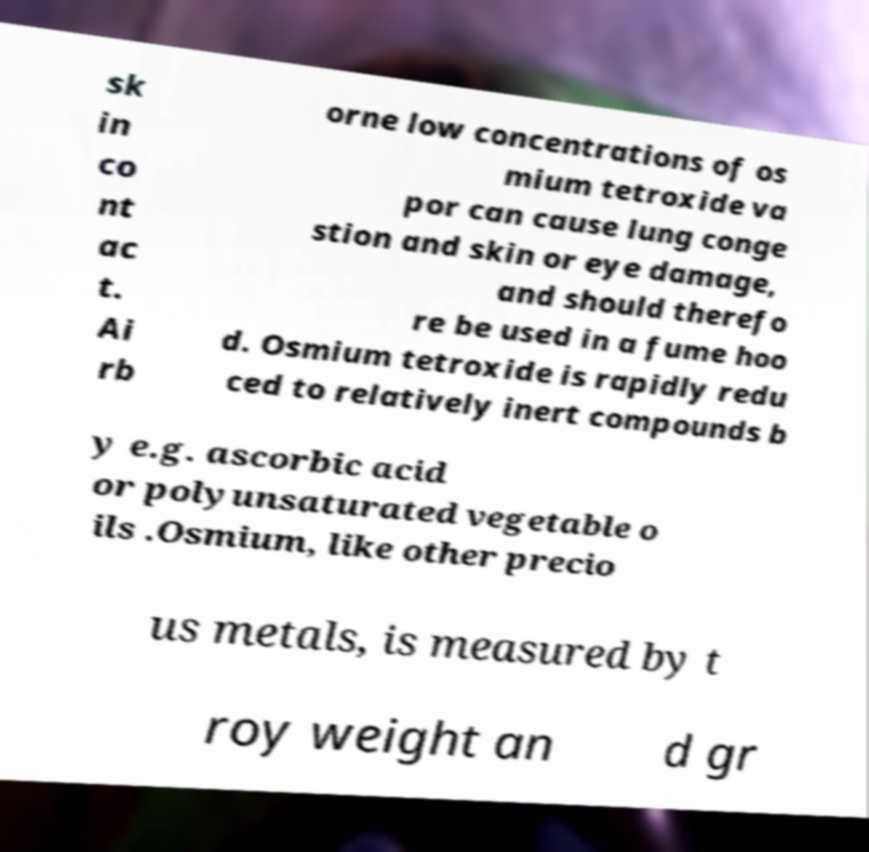Could you extract and type out the text from this image? sk in co nt ac t. Ai rb orne low concentrations of os mium tetroxide va por can cause lung conge stion and skin or eye damage, and should therefo re be used in a fume hoo d. Osmium tetroxide is rapidly redu ced to relatively inert compounds b y e.g. ascorbic acid or polyunsaturated vegetable o ils .Osmium, like other precio us metals, is measured by t roy weight an d gr 